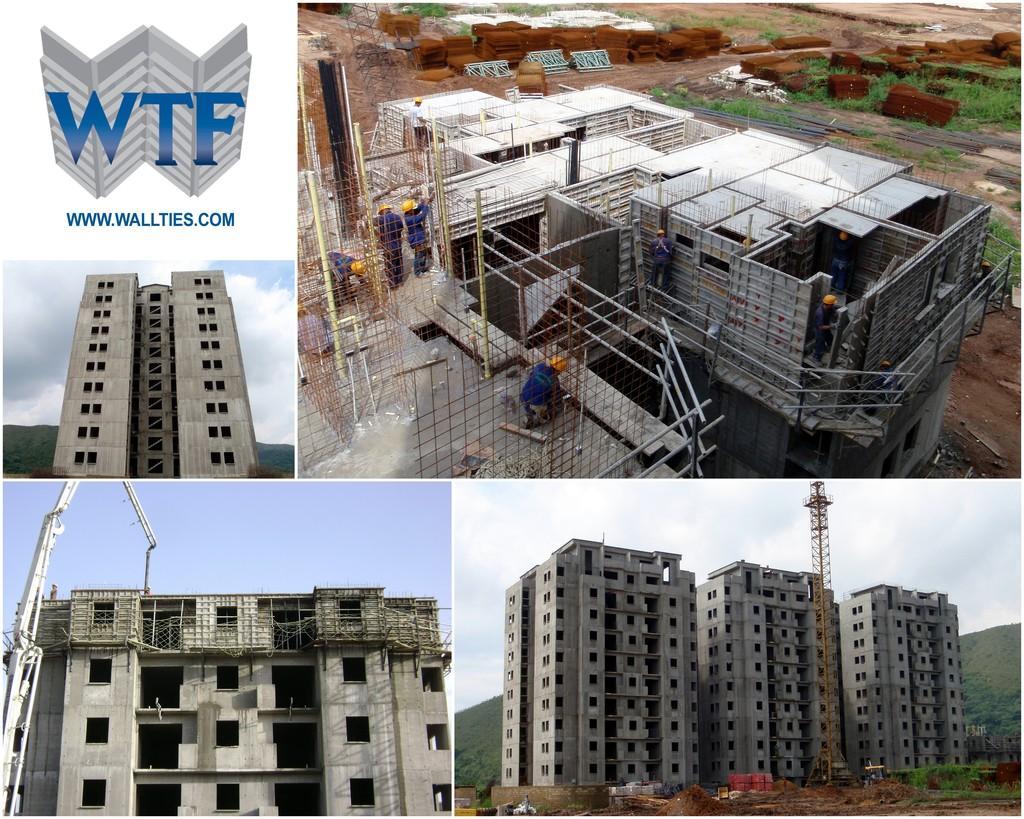How would you summarize this image in a sentence or two? This image is a collage. In the first image we can see a building. In the second image we can see people constructing a building. In the third image there is a building and we can see a crane. In the fourth image we can see a crane, building, hill and sky. 